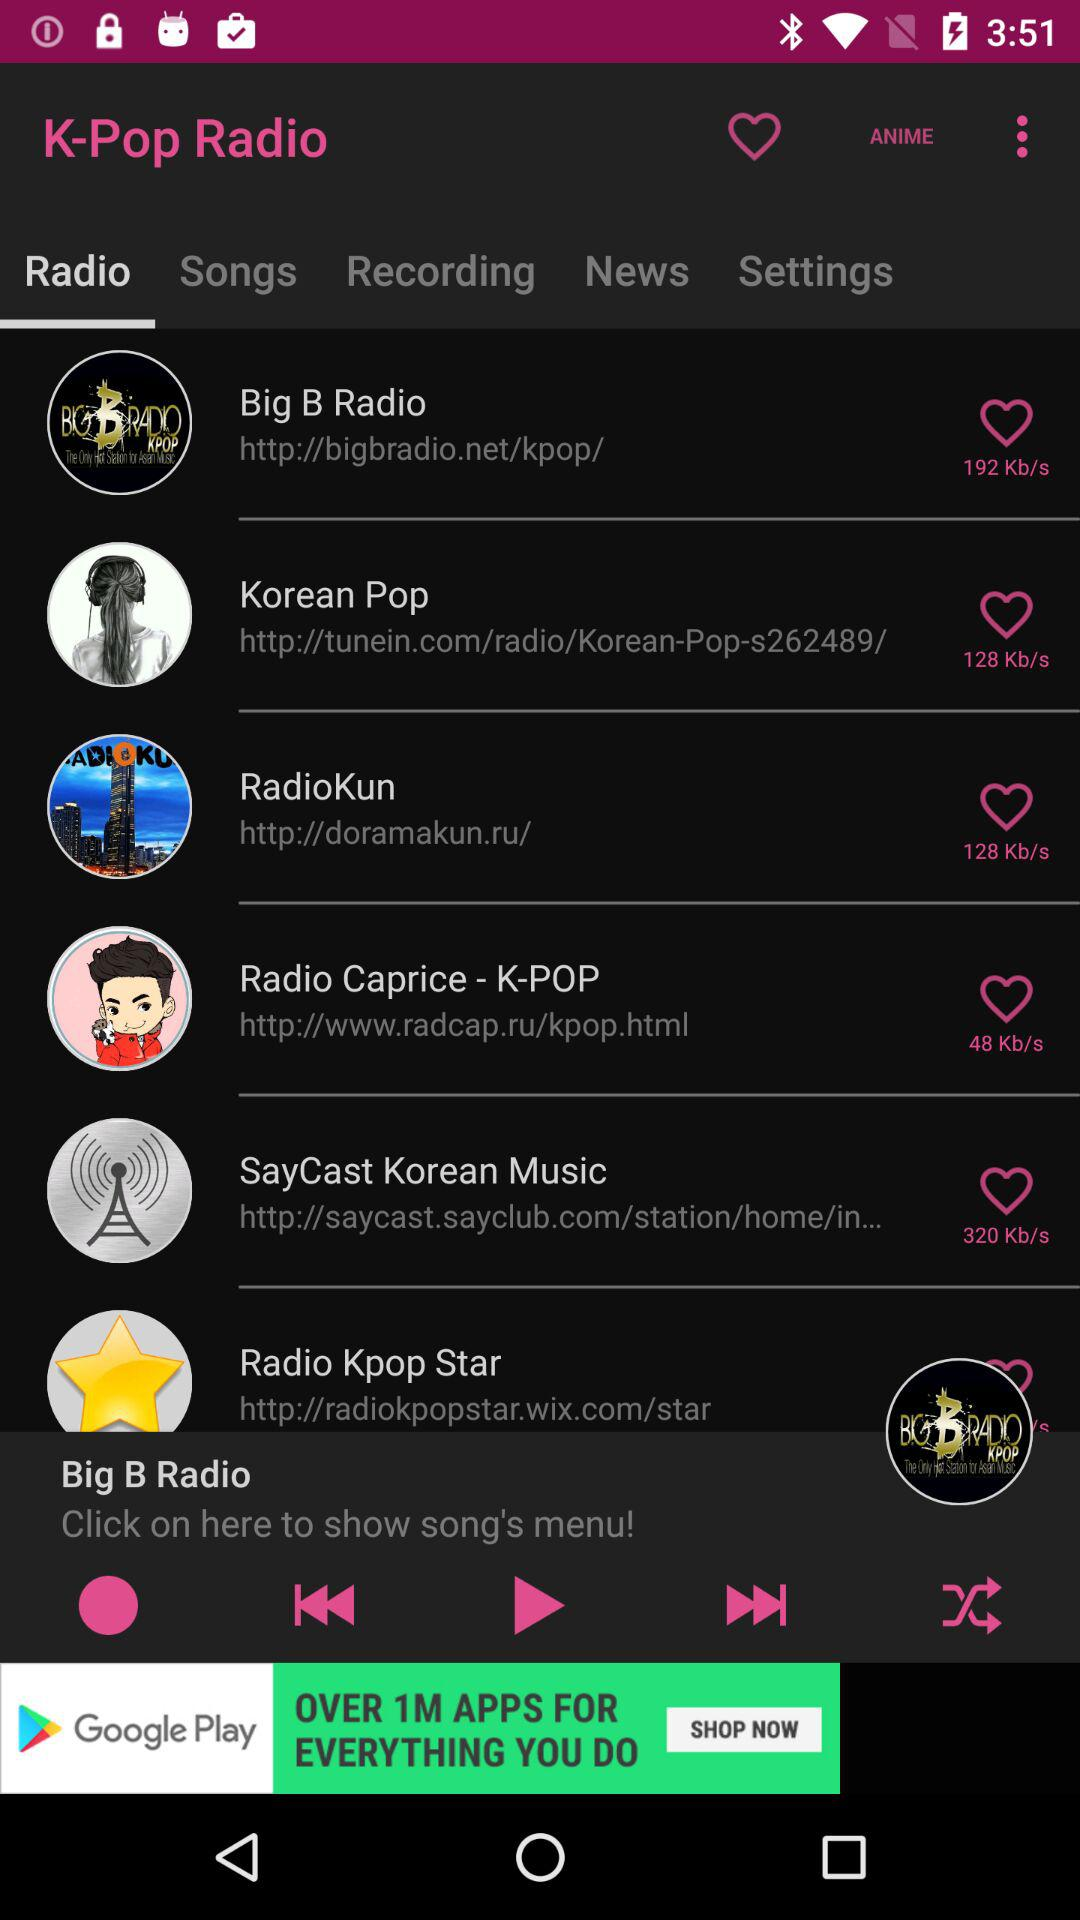What is the name of the application? The name of the application is "K-Pop Radio". 